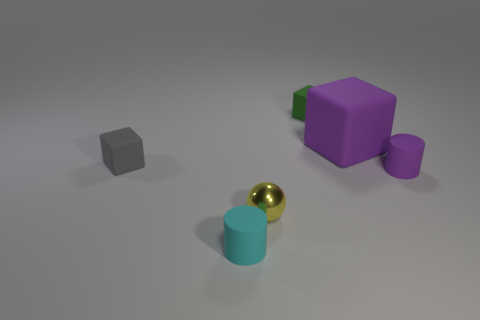Add 4 yellow things. How many objects exist? 10 Subtract all spheres. How many objects are left? 5 Add 2 big purple cubes. How many big purple cubes exist? 3 Subtract 1 cyan cylinders. How many objects are left? 5 Subtract all yellow spheres. Subtract all small yellow objects. How many objects are left? 4 Add 1 tiny cyan matte objects. How many tiny cyan matte objects are left? 2 